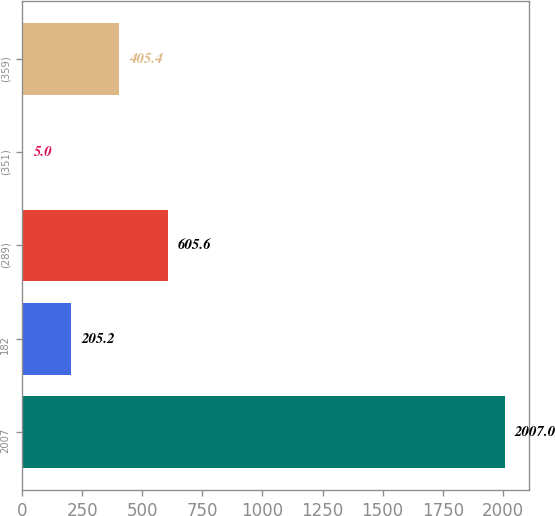Convert chart to OTSL. <chart><loc_0><loc_0><loc_500><loc_500><bar_chart><fcel>2007<fcel>182<fcel>(289)<fcel>(351)<fcel>(359)<nl><fcel>2007<fcel>205.2<fcel>605.6<fcel>5<fcel>405.4<nl></chart> 